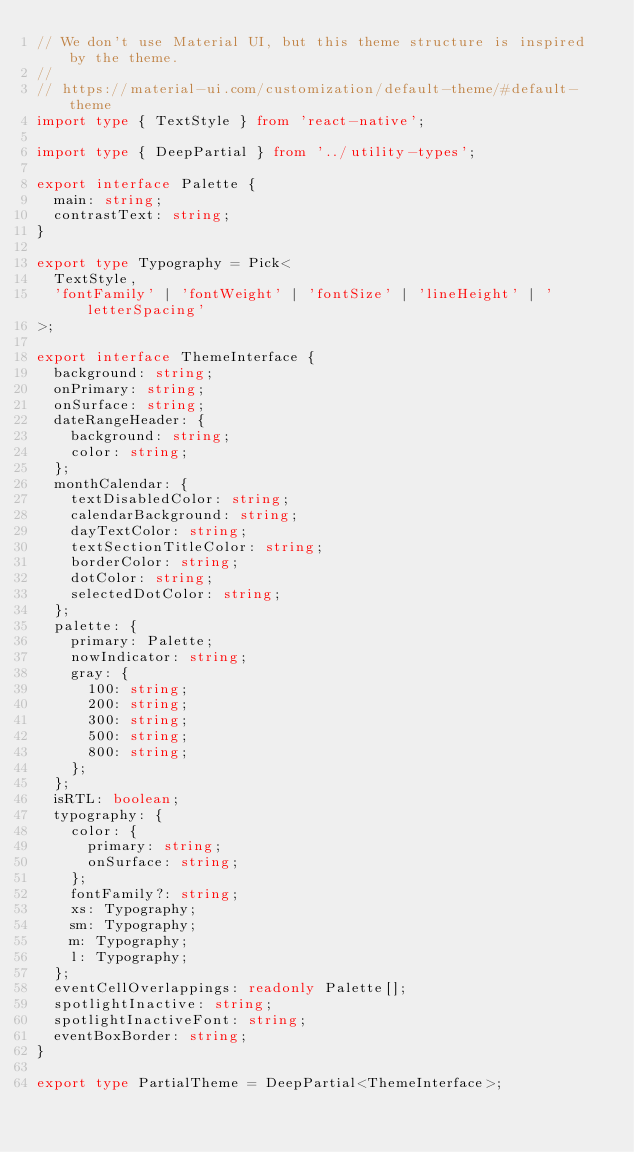<code> <loc_0><loc_0><loc_500><loc_500><_TypeScript_>// We don't use Material UI, but this theme structure is inspired by the theme.
//
// https://material-ui.com/customization/default-theme/#default-theme
import type { TextStyle } from 'react-native';

import type { DeepPartial } from '../utility-types';

export interface Palette {
  main: string;
  contrastText: string;
}

export type Typography = Pick<
  TextStyle,
  'fontFamily' | 'fontWeight' | 'fontSize' | 'lineHeight' | 'letterSpacing'
>;

export interface ThemeInterface {
  background: string;
  onPrimary: string;
  onSurface: string;
  dateRangeHeader: {
    background: string;
    color: string;
  };
  monthCalendar: {
    textDisabledColor: string;
    calendarBackground: string;
    dayTextColor: string;
    textSectionTitleColor: string;
    borderColor: string;
    dotColor: string;
    selectedDotColor: string;
  };
  palette: {
    primary: Palette;
    nowIndicator: string;
    gray: {
      100: string;
      200: string;
      300: string;
      500: string;
      800: string;
    };
  };
  isRTL: boolean;
  typography: {
    color: {
      primary: string;
      onSurface: string;
    };
    fontFamily?: string;
    xs: Typography;
    sm: Typography;
    m: Typography;
    l: Typography;
  };
  eventCellOverlappings: readonly Palette[];
  spotlightInactive: string;
  spotlightInactiveFont: string;
  eventBoxBorder: string;
}

export type PartialTheme = DeepPartial<ThemeInterface>;
</code> 